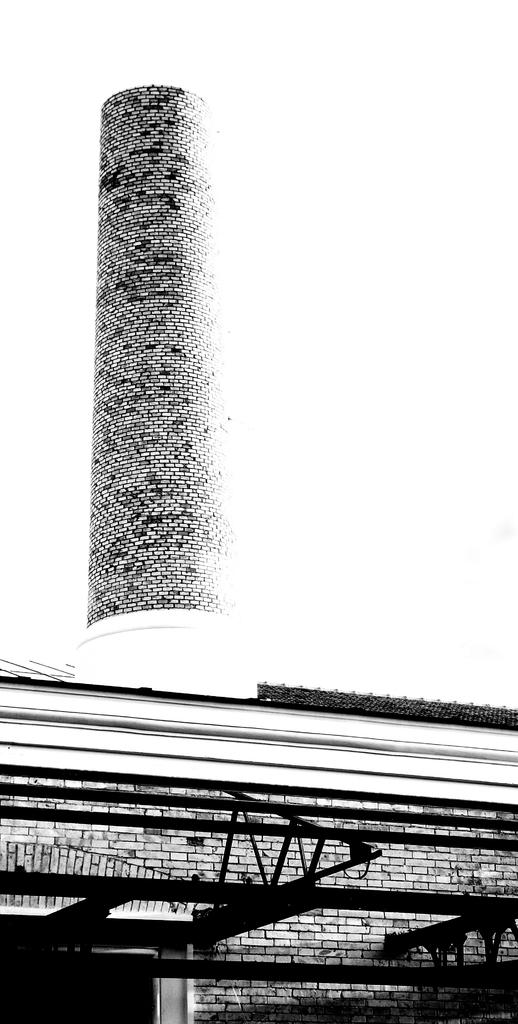What type of picture is in the image? The image contains a black and white picture of a building. What material is the wall made of in the image? There is a brick wall visible in the image. What part of the natural environment is visible in the image? The sky is visible in the image. What type of linen is draped over the front of the building in the image? There is no linen draped over the front of the building in the image; it is a black and white picture of a building with a brick wall and visible sky. 